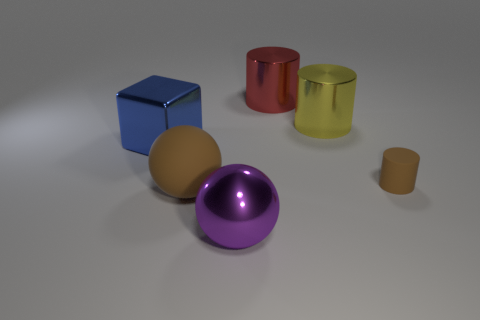Add 2 blue blocks. How many objects exist? 8 Subtract all small rubber cylinders. How many cylinders are left? 2 Subtract all cubes. How many objects are left? 5 Subtract 1 cylinders. How many cylinders are left? 2 Subtract all cyan balls. Subtract all yellow blocks. How many balls are left? 2 Subtract all small blue shiny cubes. Subtract all yellow things. How many objects are left? 5 Add 4 yellow shiny objects. How many yellow shiny objects are left? 5 Add 6 big cubes. How many big cubes exist? 7 Subtract all brown cylinders. How many cylinders are left? 2 Subtract 1 purple balls. How many objects are left? 5 